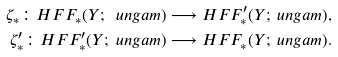<formula> <loc_0><loc_0><loc_500><loc_500>\zeta _ { * } \colon H F F _ { * } ( Y ; \ u n g a m ) & \longrightarrow H F F _ { * } ^ { \prime } ( Y ; \ u n g a m ) , \\ \zeta ^ { \prime } _ { * } \colon H F F _ { * } ^ { \prime } ( Y ; \ u n g a m ) & \longrightarrow H F F _ { * } ( Y ; \ u n g a m ) .</formula> 